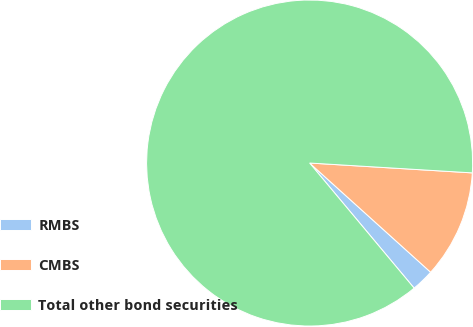Convert chart. <chart><loc_0><loc_0><loc_500><loc_500><pie_chart><fcel>RMBS<fcel>CMBS<fcel>Total other bond securities<nl><fcel>2.24%<fcel>10.72%<fcel>87.05%<nl></chart> 